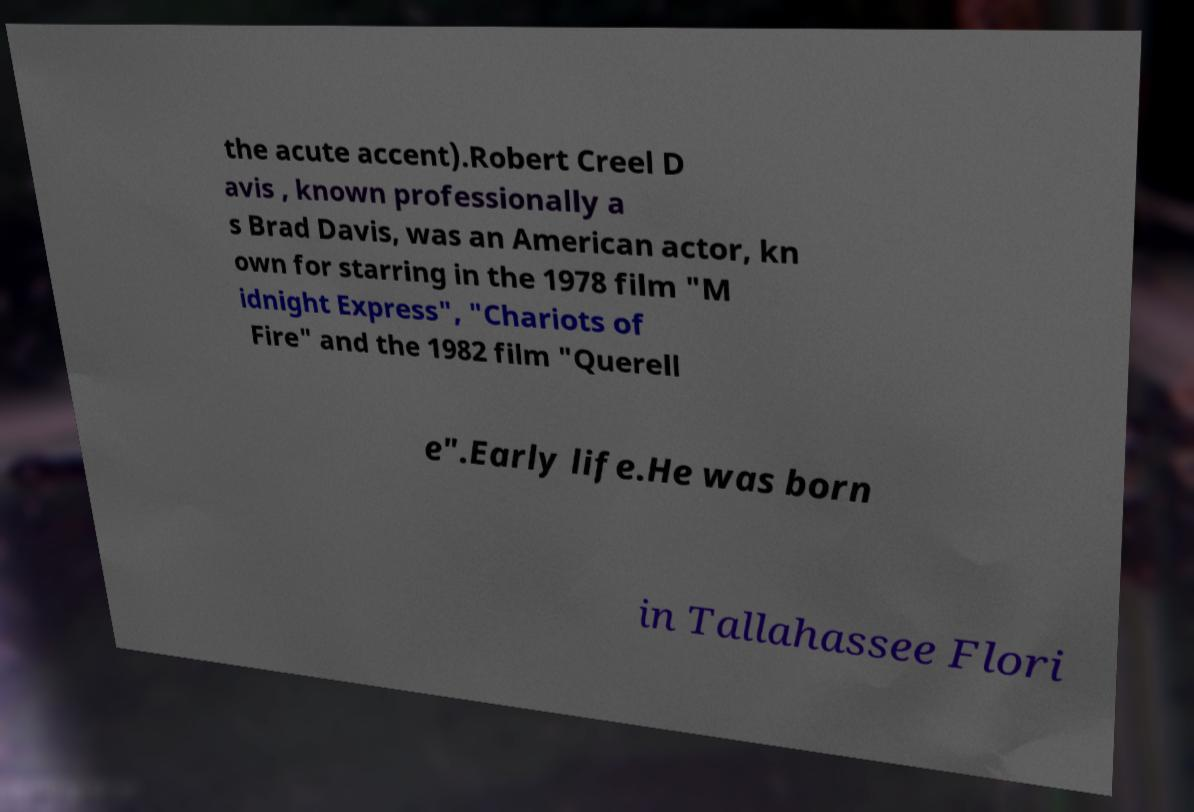I need the written content from this picture converted into text. Can you do that? the acute accent).Robert Creel D avis , known professionally a s Brad Davis, was an American actor, kn own for starring in the 1978 film "M idnight Express", "Chariots of Fire" and the 1982 film "Querell e".Early life.He was born in Tallahassee Flori 